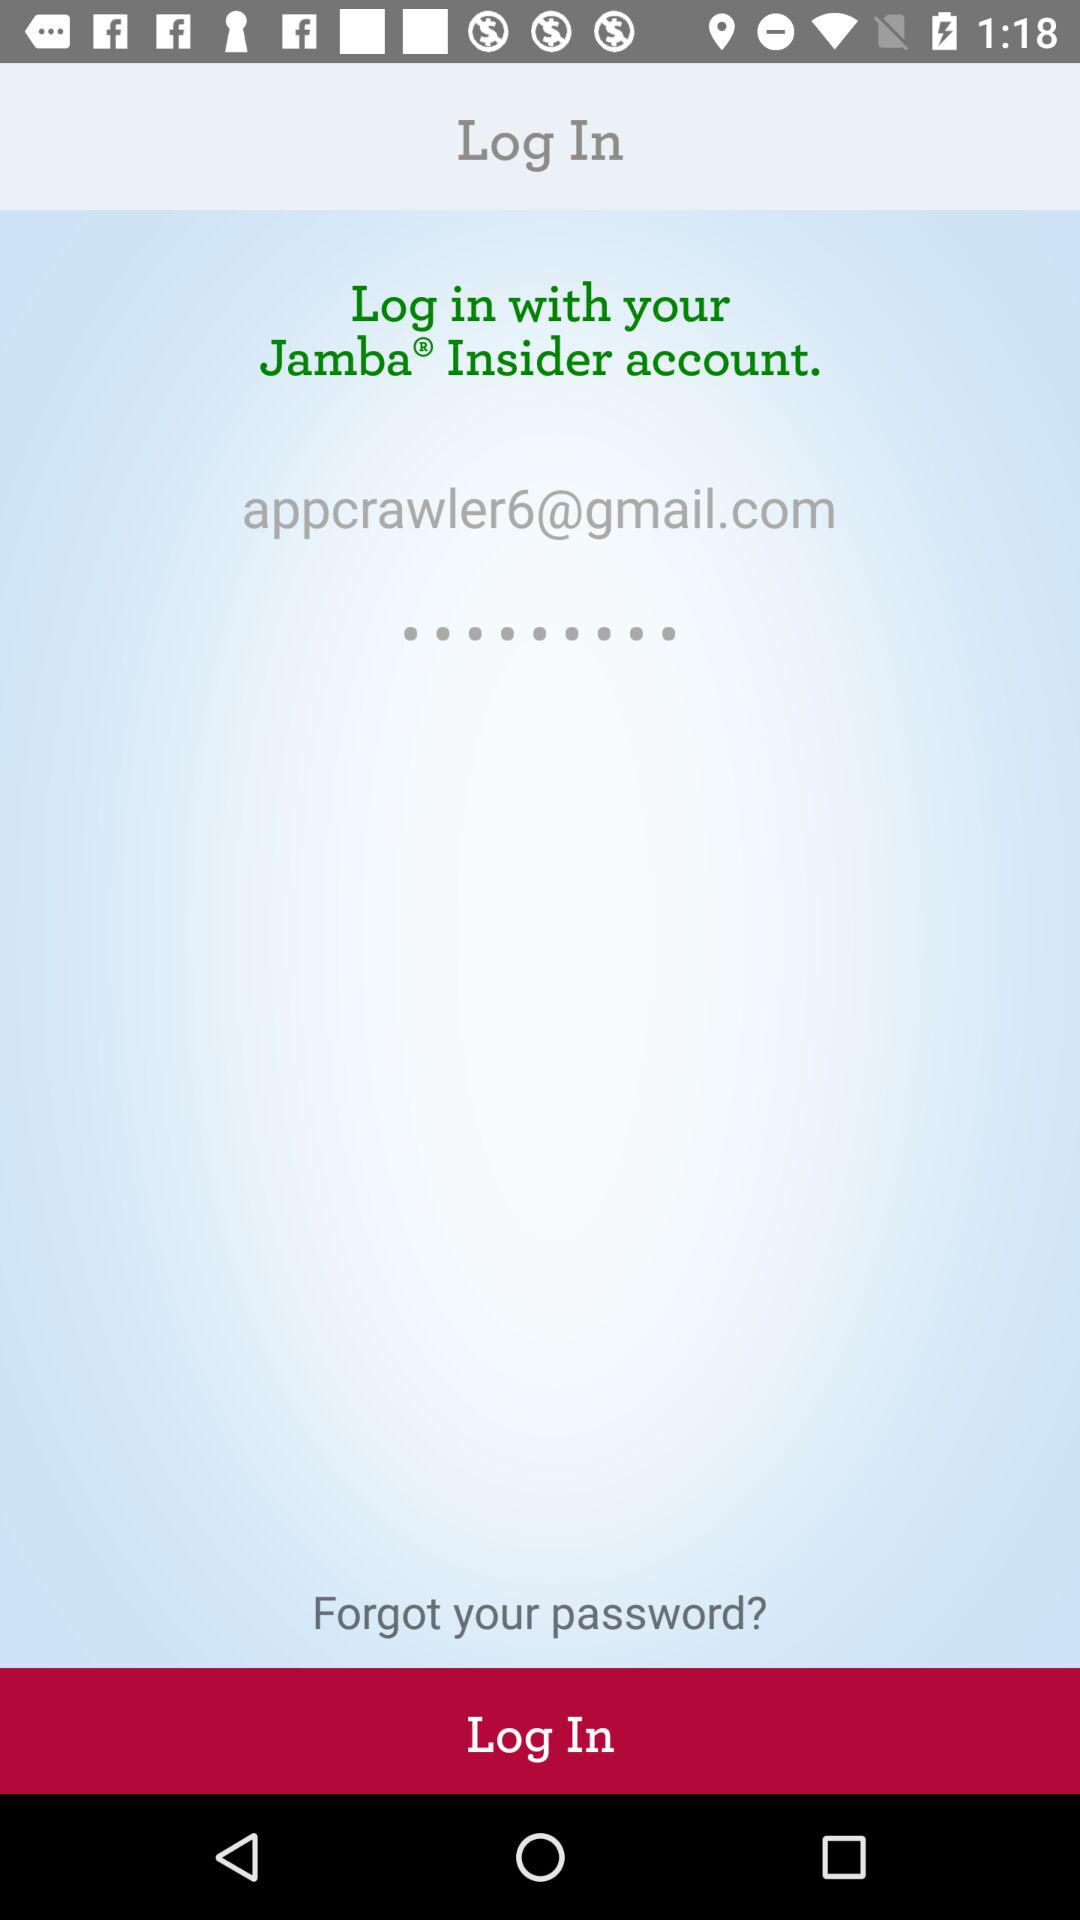What is the email address? The email address is appcrawler6@gmail.com. 